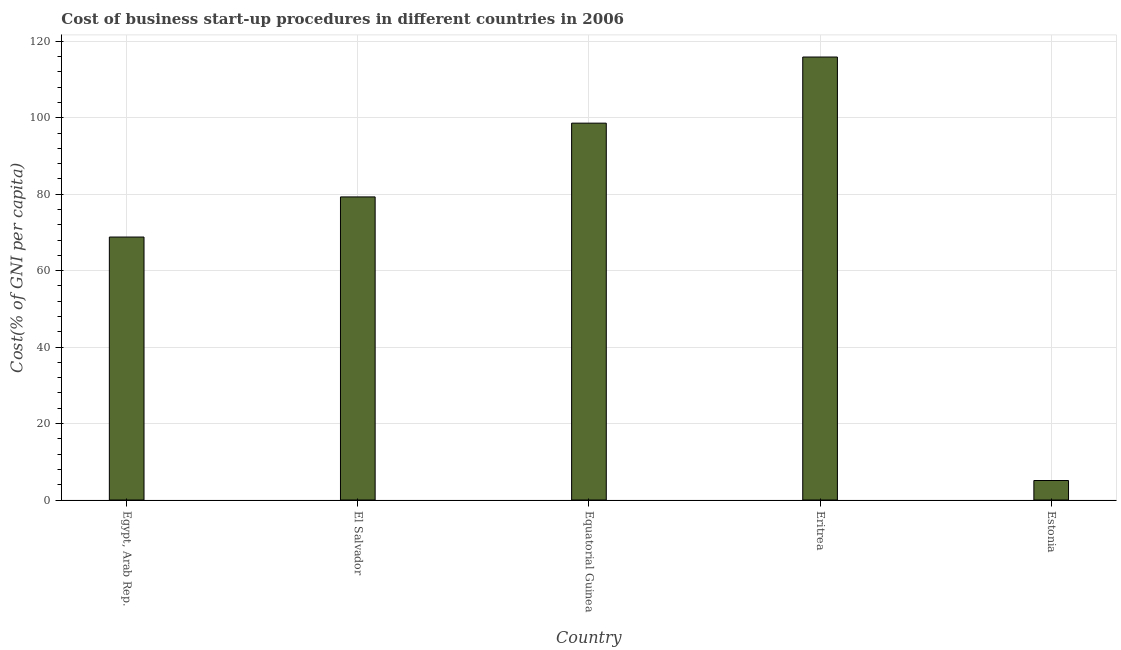Does the graph contain grids?
Provide a short and direct response. Yes. What is the title of the graph?
Ensure brevity in your answer.  Cost of business start-up procedures in different countries in 2006. What is the label or title of the Y-axis?
Your response must be concise. Cost(% of GNI per capita). What is the cost of business startup procedures in Equatorial Guinea?
Your response must be concise. 98.6. Across all countries, what is the maximum cost of business startup procedures?
Ensure brevity in your answer.  115.9. Across all countries, what is the minimum cost of business startup procedures?
Offer a terse response. 5.1. In which country was the cost of business startup procedures maximum?
Your answer should be very brief. Eritrea. In which country was the cost of business startup procedures minimum?
Provide a short and direct response. Estonia. What is the sum of the cost of business startup procedures?
Provide a succinct answer. 367.7. What is the difference between the cost of business startup procedures in Egypt, Arab Rep. and Eritrea?
Offer a terse response. -47.1. What is the average cost of business startup procedures per country?
Your answer should be very brief. 73.54. What is the median cost of business startup procedures?
Offer a terse response. 79.3. What is the ratio of the cost of business startup procedures in Eritrea to that in Estonia?
Make the answer very short. 22.73. Is the difference between the cost of business startup procedures in Egypt, Arab Rep. and El Salvador greater than the difference between any two countries?
Your response must be concise. No. Is the sum of the cost of business startup procedures in Egypt, Arab Rep. and Estonia greater than the maximum cost of business startup procedures across all countries?
Your answer should be compact. No. What is the difference between the highest and the lowest cost of business startup procedures?
Provide a short and direct response. 110.8. How many bars are there?
Ensure brevity in your answer.  5. What is the Cost(% of GNI per capita) of Egypt, Arab Rep.?
Make the answer very short. 68.8. What is the Cost(% of GNI per capita) in El Salvador?
Offer a terse response. 79.3. What is the Cost(% of GNI per capita) in Equatorial Guinea?
Ensure brevity in your answer.  98.6. What is the Cost(% of GNI per capita) of Eritrea?
Ensure brevity in your answer.  115.9. What is the Cost(% of GNI per capita) in Estonia?
Offer a terse response. 5.1. What is the difference between the Cost(% of GNI per capita) in Egypt, Arab Rep. and Equatorial Guinea?
Provide a short and direct response. -29.8. What is the difference between the Cost(% of GNI per capita) in Egypt, Arab Rep. and Eritrea?
Offer a terse response. -47.1. What is the difference between the Cost(% of GNI per capita) in Egypt, Arab Rep. and Estonia?
Give a very brief answer. 63.7. What is the difference between the Cost(% of GNI per capita) in El Salvador and Equatorial Guinea?
Offer a very short reply. -19.3. What is the difference between the Cost(% of GNI per capita) in El Salvador and Eritrea?
Give a very brief answer. -36.6. What is the difference between the Cost(% of GNI per capita) in El Salvador and Estonia?
Your answer should be very brief. 74.2. What is the difference between the Cost(% of GNI per capita) in Equatorial Guinea and Eritrea?
Keep it short and to the point. -17.3. What is the difference between the Cost(% of GNI per capita) in Equatorial Guinea and Estonia?
Give a very brief answer. 93.5. What is the difference between the Cost(% of GNI per capita) in Eritrea and Estonia?
Your answer should be very brief. 110.8. What is the ratio of the Cost(% of GNI per capita) in Egypt, Arab Rep. to that in El Salvador?
Your response must be concise. 0.87. What is the ratio of the Cost(% of GNI per capita) in Egypt, Arab Rep. to that in Equatorial Guinea?
Offer a very short reply. 0.7. What is the ratio of the Cost(% of GNI per capita) in Egypt, Arab Rep. to that in Eritrea?
Give a very brief answer. 0.59. What is the ratio of the Cost(% of GNI per capita) in Egypt, Arab Rep. to that in Estonia?
Offer a terse response. 13.49. What is the ratio of the Cost(% of GNI per capita) in El Salvador to that in Equatorial Guinea?
Your answer should be very brief. 0.8. What is the ratio of the Cost(% of GNI per capita) in El Salvador to that in Eritrea?
Make the answer very short. 0.68. What is the ratio of the Cost(% of GNI per capita) in El Salvador to that in Estonia?
Your answer should be compact. 15.55. What is the ratio of the Cost(% of GNI per capita) in Equatorial Guinea to that in Eritrea?
Ensure brevity in your answer.  0.85. What is the ratio of the Cost(% of GNI per capita) in Equatorial Guinea to that in Estonia?
Your answer should be very brief. 19.33. What is the ratio of the Cost(% of GNI per capita) in Eritrea to that in Estonia?
Make the answer very short. 22.73. 